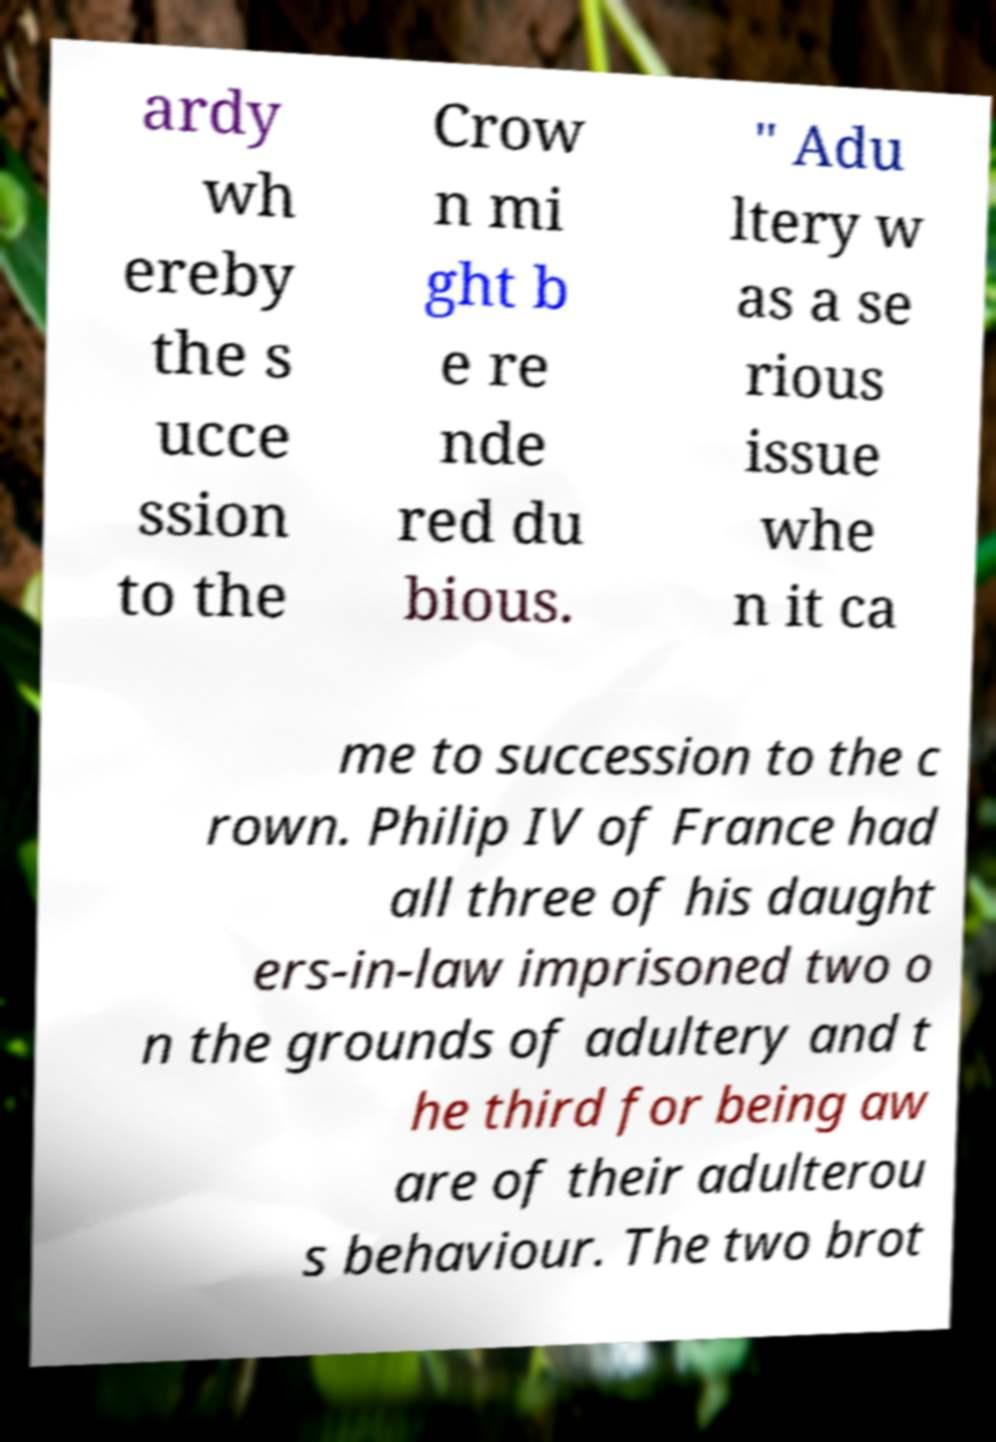Could you extract and type out the text from this image? ardy wh ereby the s ucce ssion to the Crow n mi ght b e re nde red du bious. " Adu ltery w as a se rious issue whe n it ca me to succession to the c rown. Philip IV of France had all three of his daught ers-in-law imprisoned two o n the grounds of adultery and t he third for being aw are of their adulterou s behaviour. The two brot 